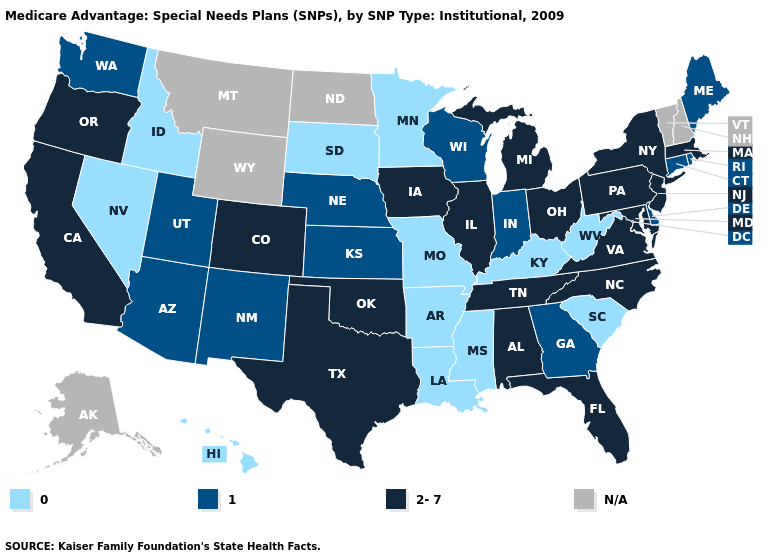How many symbols are there in the legend?
Give a very brief answer. 4. What is the lowest value in the USA?
Quick response, please. 0. How many symbols are there in the legend?
Be succinct. 4. Does Louisiana have the lowest value in the USA?
Answer briefly. Yes. Name the states that have a value in the range 2-7?
Be succinct. Alabama, California, Colorado, Florida, Iowa, Illinois, Massachusetts, Maryland, Michigan, North Carolina, New Jersey, New York, Ohio, Oklahoma, Oregon, Pennsylvania, Tennessee, Texas, Virginia. Name the states that have a value in the range 0?
Write a very short answer. Arkansas, Hawaii, Idaho, Kentucky, Louisiana, Minnesota, Missouri, Mississippi, Nevada, South Carolina, South Dakota, West Virginia. What is the value of Connecticut?
Answer briefly. 1. Does Pennsylvania have the lowest value in the USA?
Keep it brief. No. What is the value of Florida?
Short answer required. 2-7. Does Pennsylvania have the highest value in the USA?
Short answer required. Yes. What is the highest value in states that border Indiana?
Answer briefly. 2-7. Is the legend a continuous bar?
Concise answer only. No. What is the value of Mississippi?
Give a very brief answer. 0. What is the highest value in the USA?
Keep it brief. 2-7. 